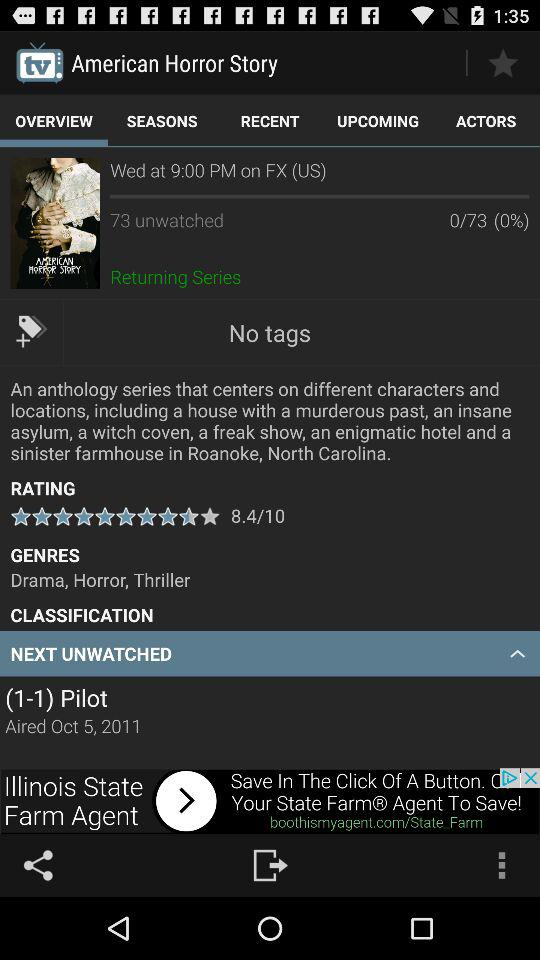What is the show time? The show time is 9:00 PM. 